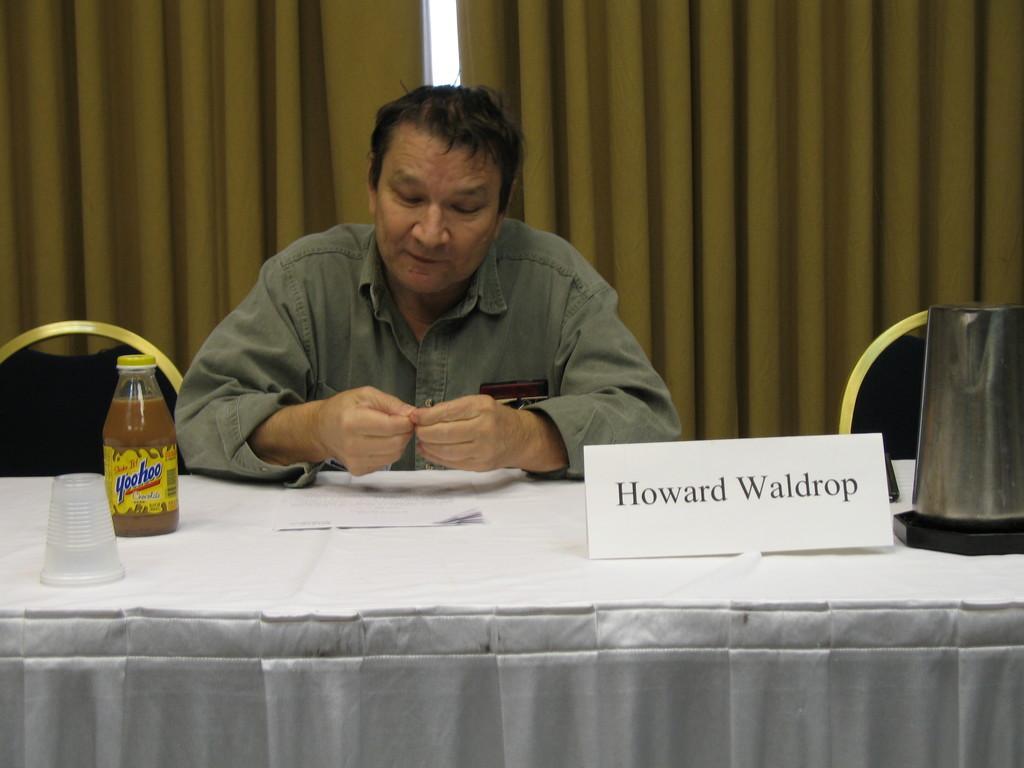Describe this image in one or two sentences. In this image there is one person who is sitting and looking at his fingers. In front of him there is one table on the right side there is one flask beside that flask one name plate is there and on the left side there is one bottle and beside bottle one glass is there on the right side and left side there are curtains and in the middle of the image there is one window and there are two chairs at the left and right side. 